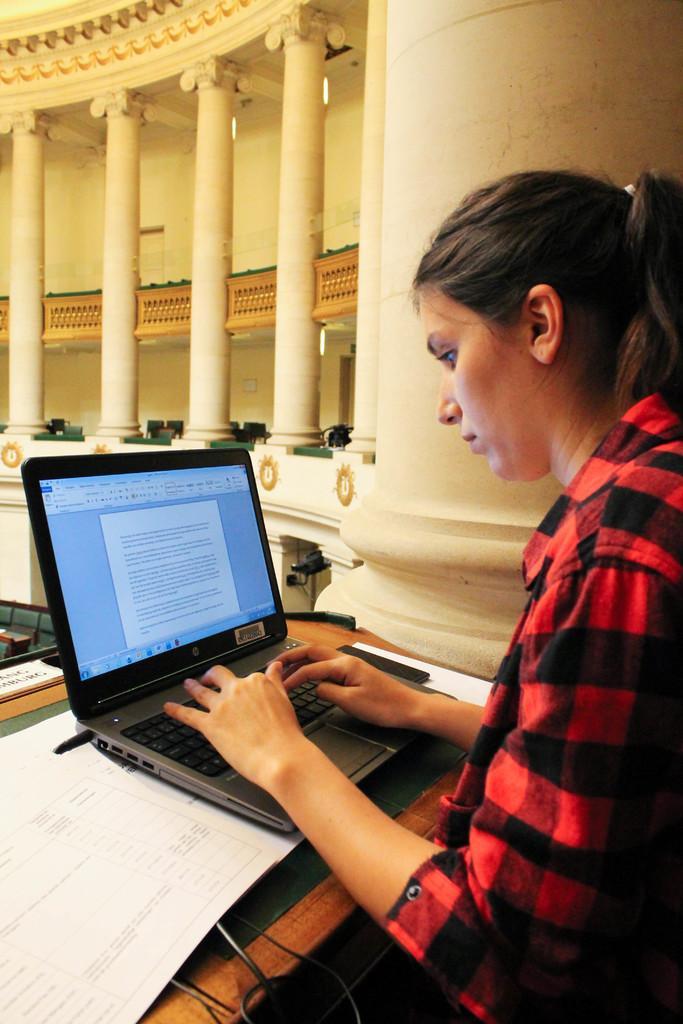In one or two sentences, can you explain what this image depicts? This picture seems to be clicked inside. In the foreground there is a person wearing red color shirt, sitting and working on a laptop and there are some items placed on the wooden table. In the background we can see the pillars of the building and the walls and guard rails of the building. 